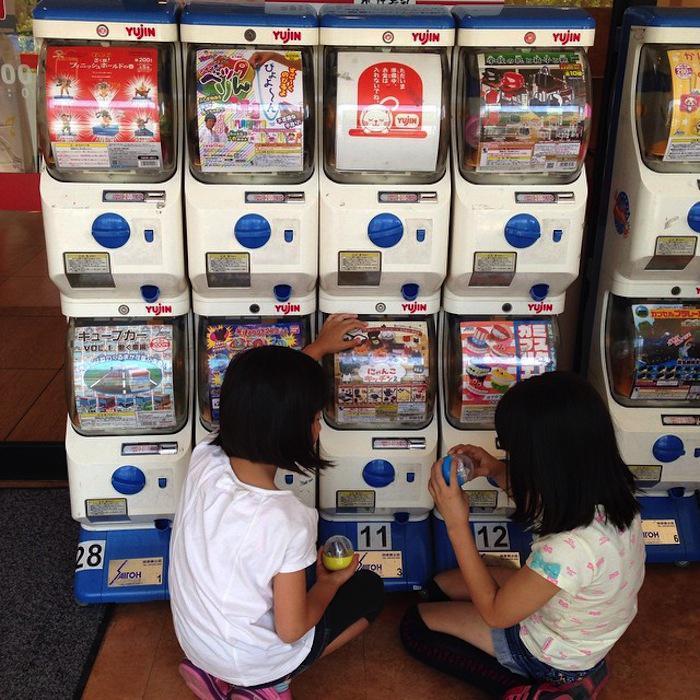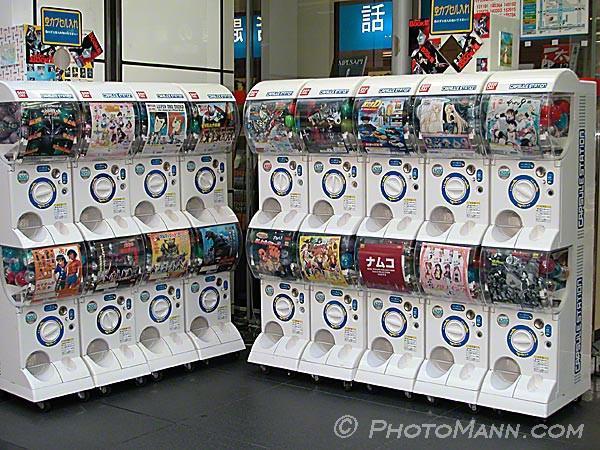The first image is the image on the left, the second image is the image on the right. For the images displayed, is the sentence "There are toy vending machines in both images." factually correct? Answer yes or no. Yes. 